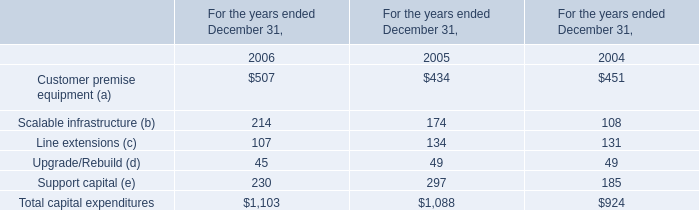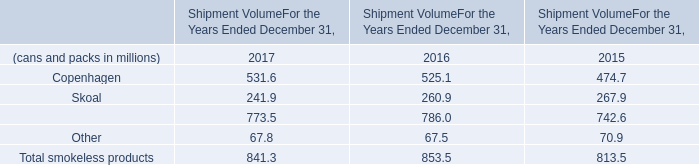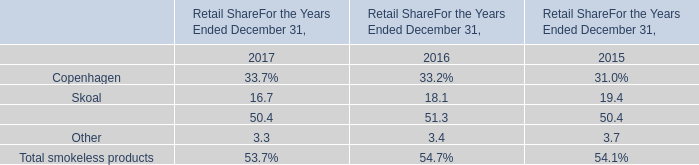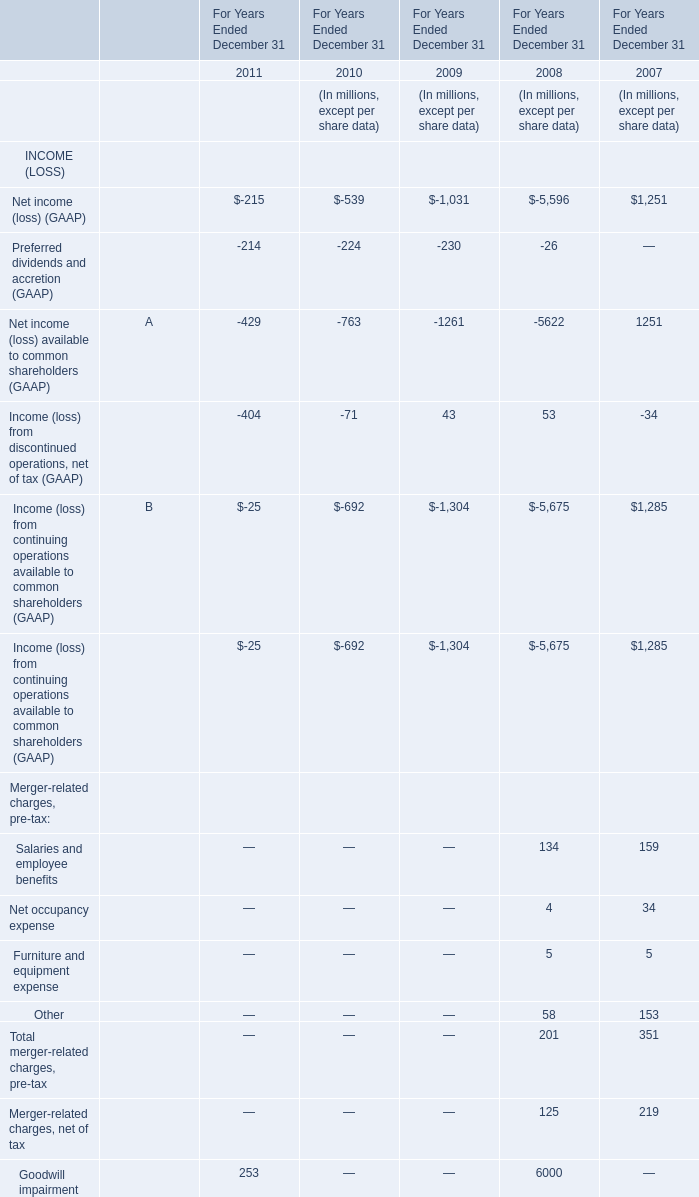How long does Income (loss) from discontinued operations, net of tax (GAAP) keep growing? 
Computations: (2008 - 2007)
Answer: 1.0. 